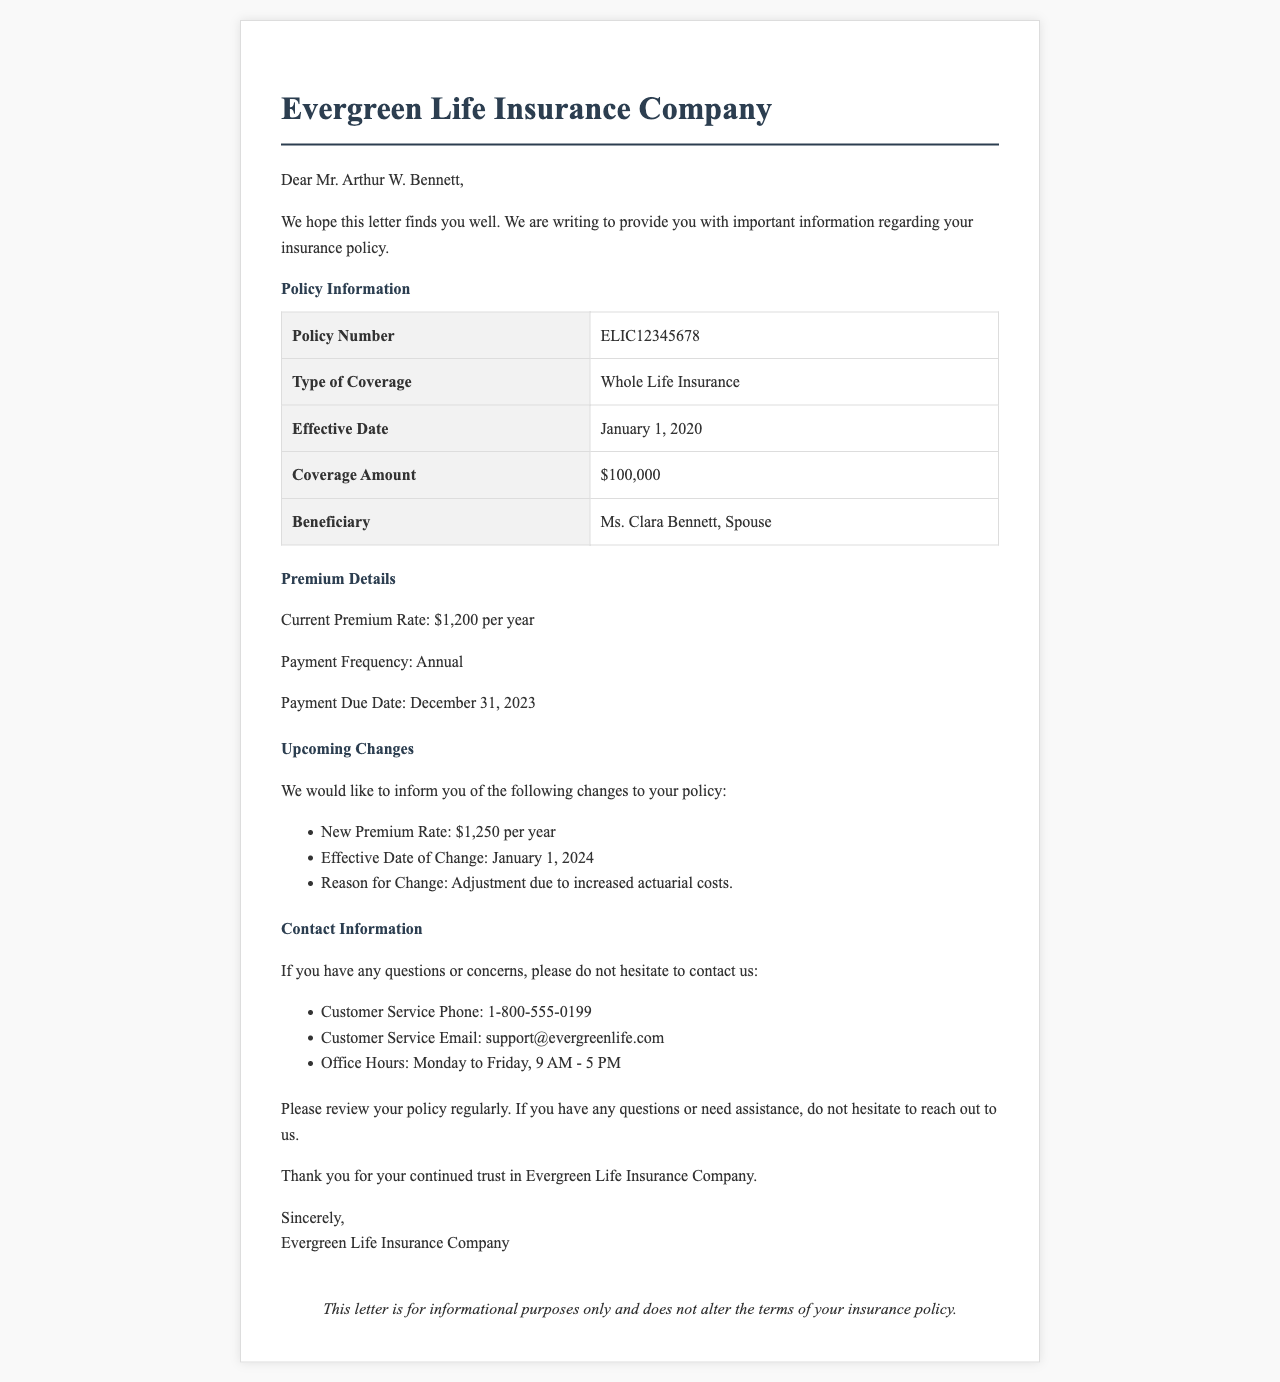What is the policy number? The policy number is explicitly stated in the document under Policy Information.
Answer: ELIC12345678 What is the type of coverage? The type of coverage is mentioned in the same section, providing insight into the insurance category.
Answer: Whole Life Insurance When is the payment due date? The payment due date is presented in the Premium Details section, indicating when the premium should be paid.
Answer: December 31, 2023 What is the new premium rate effective next year? The document specifies the new premium rate in the Upcoming Changes section, reflecting the updated cost of the policy.
Answer: $1,250 per year Who is the beneficiary of the policy? The beneficiary's name is mentioned in the Policy Information section, clarifying who will receive the benefit.
Answer: Ms. Clara Bennett, Spouse Why is the premium rate changing? The reason for the change in premium rate is provided in the Upcoming Changes section of the letter.
Answer: Adjustment due to increased actuarial costs What is the effective date of the new premium rate? The effective date of the new premium rate is also specified in the Upcoming Changes section of the document.
Answer: January 1, 2024 What is the customer service phone number? The contact information section includes the customer service phone number for inquiries regarding the policy.
Answer: 1-800-555-0199 